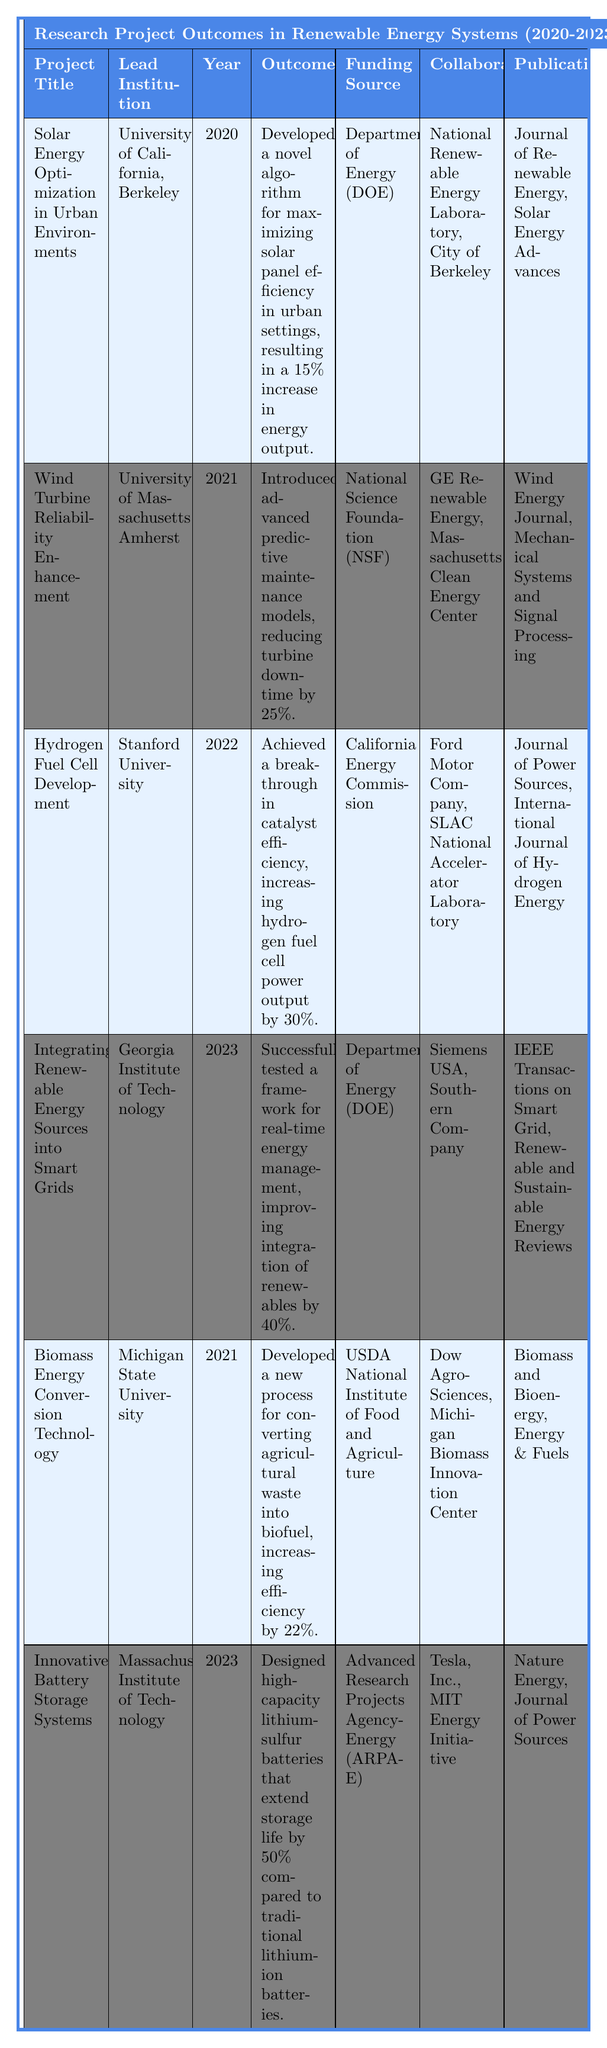What is the outcome of the project "Solar Energy Optimization in Urban Environments"? According to the table, this project developed a novel algorithm for maximizing solar panel efficiency, resulting in a 15% increase in energy output.
Answer: Developed a novel algorithm for maximizing solar panel efficiency in urban settings, resulting in a 15% increase in energy output Who funded the project on "Hydrogen Fuel Cell Development"? The table indicates that this project was funded by the California Energy Commission.
Answer: California Energy Commission Which university led the "Wind Turbine Reliability Enhancement" project? The table shows that the University of Massachusetts Amherst was the lead institution for this project.
Answer: University of Massachusetts Amherst How many projects were conducted in 2023? By reviewing the table, there are two projects listed under the year 2023: "Integrating Renewable Energy Sources into Smart Grids" and "Innovative Battery Storage Systems."
Answer: 2 What was the average increase in energy output for the projects, if applicable? The increase in energy output is documented as 15% for "Solar Energy Optimization", 30% for "Hydrogen Fuel Cell Development", and 40% for "Integrating Renewable Energy Sources into Smart Grids". Adding these up gives 15 + 30 + 40 = 85, now divide by the number of projects (3) to find the average: 85/3 = 28.33%.
Answer: 28.33% Did the "Biomass Energy Conversion Technology" project result in an efficiency increase of more than 20%? Yes, the outcome for this project states that it increased efficiency by 22%, which confirms it is more than 20%.
Answer: Yes Which collaborator was involved in projects from both 2021 and 2023? Upon examining the collaborators in the relevant years, the table indicates GE Renewable Energy for 2021 and Siemens USA for 2023, while looking through the other projects does not list any recurring collaborator in both years. Therefore, there is no collaborator from the 2021 projects who was also involved in 2023.
Answer: None Which project had the highest reported efficiency increase? The table states that the "Hydrogen Fuel Cell Development" project achieved a 30% increase in power output, while others such as the "Integrating Renewable Energy Sources into Smart Grids" project had a 40% improvement in integration, but in terms of energy output alone, 30% is the highest reported increase.
Answer: Hydrogen Fuel Cell Development (30% increase) What two journals published findings related to the "Innovative Battery Storage Systems"? According to the table, this project published findings in "Nature Energy" and "Journal of Power Sources".
Answer: Nature Energy and Journal of Power Sources Which project occurred in 2022, and what was its lead institution? The table identifies "Hydrogen Fuel Cell Development" as the project that occurred in 2022, led by Stanford University.
Answer: Hydrogen Fuel Cell Development, Stanford University 